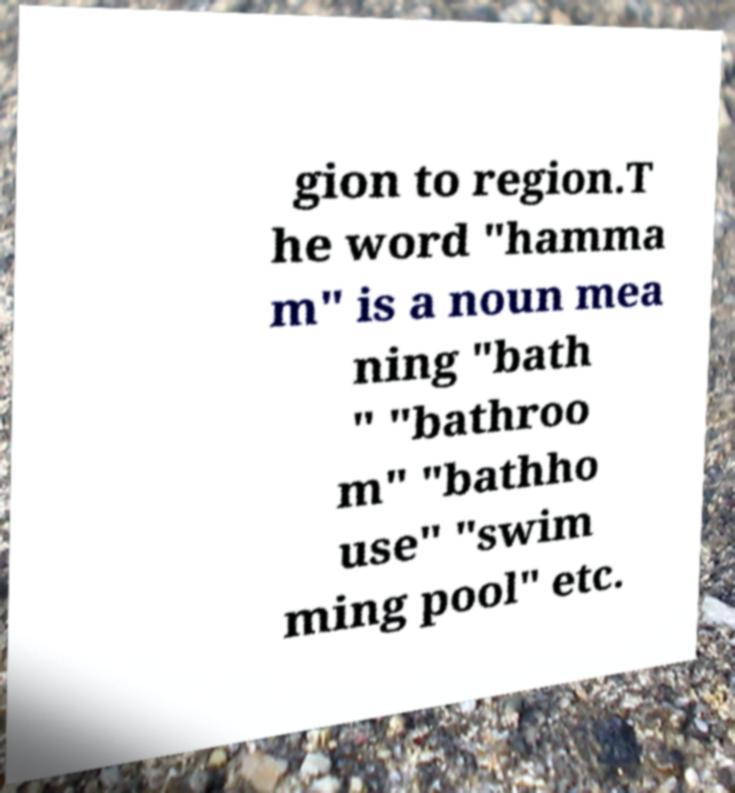Please read and relay the text visible in this image. What does it say? gion to region.T he word "hamma m" is a noun mea ning "bath " "bathroo m" "bathho use" "swim ming pool" etc. 